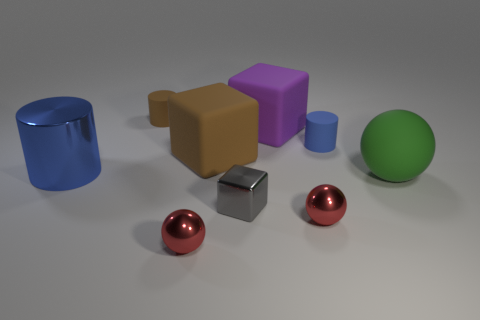There is a tiny cylinder that is the same color as the big metallic thing; what material is it?
Your response must be concise. Rubber. Are there more small gray cubes that are to the right of the big green rubber object than big brown matte cubes?
Ensure brevity in your answer.  No. The purple thing that is the same shape as the gray object is what size?
Ensure brevity in your answer.  Large. Is there any other thing that is the same material as the tiny brown thing?
Give a very brief answer. Yes. What is the shape of the small brown thing?
Give a very brief answer. Cylinder. What shape is the brown thing that is the same size as the blue metallic object?
Provide a short and direct response. Cube. Is there anything else that is the same color as the small block?
Make the answer very short. No. What is the size of the gray object that is made of the same material as the big blue thing?
Your answer should be compact. Small. There is a small brown thing; does it have the same shape as the big green matte object on the right side of the large purple matte thing?
Give a very brief answer. No. The blue matte thing is what size?
Make the answer very short. Small. 